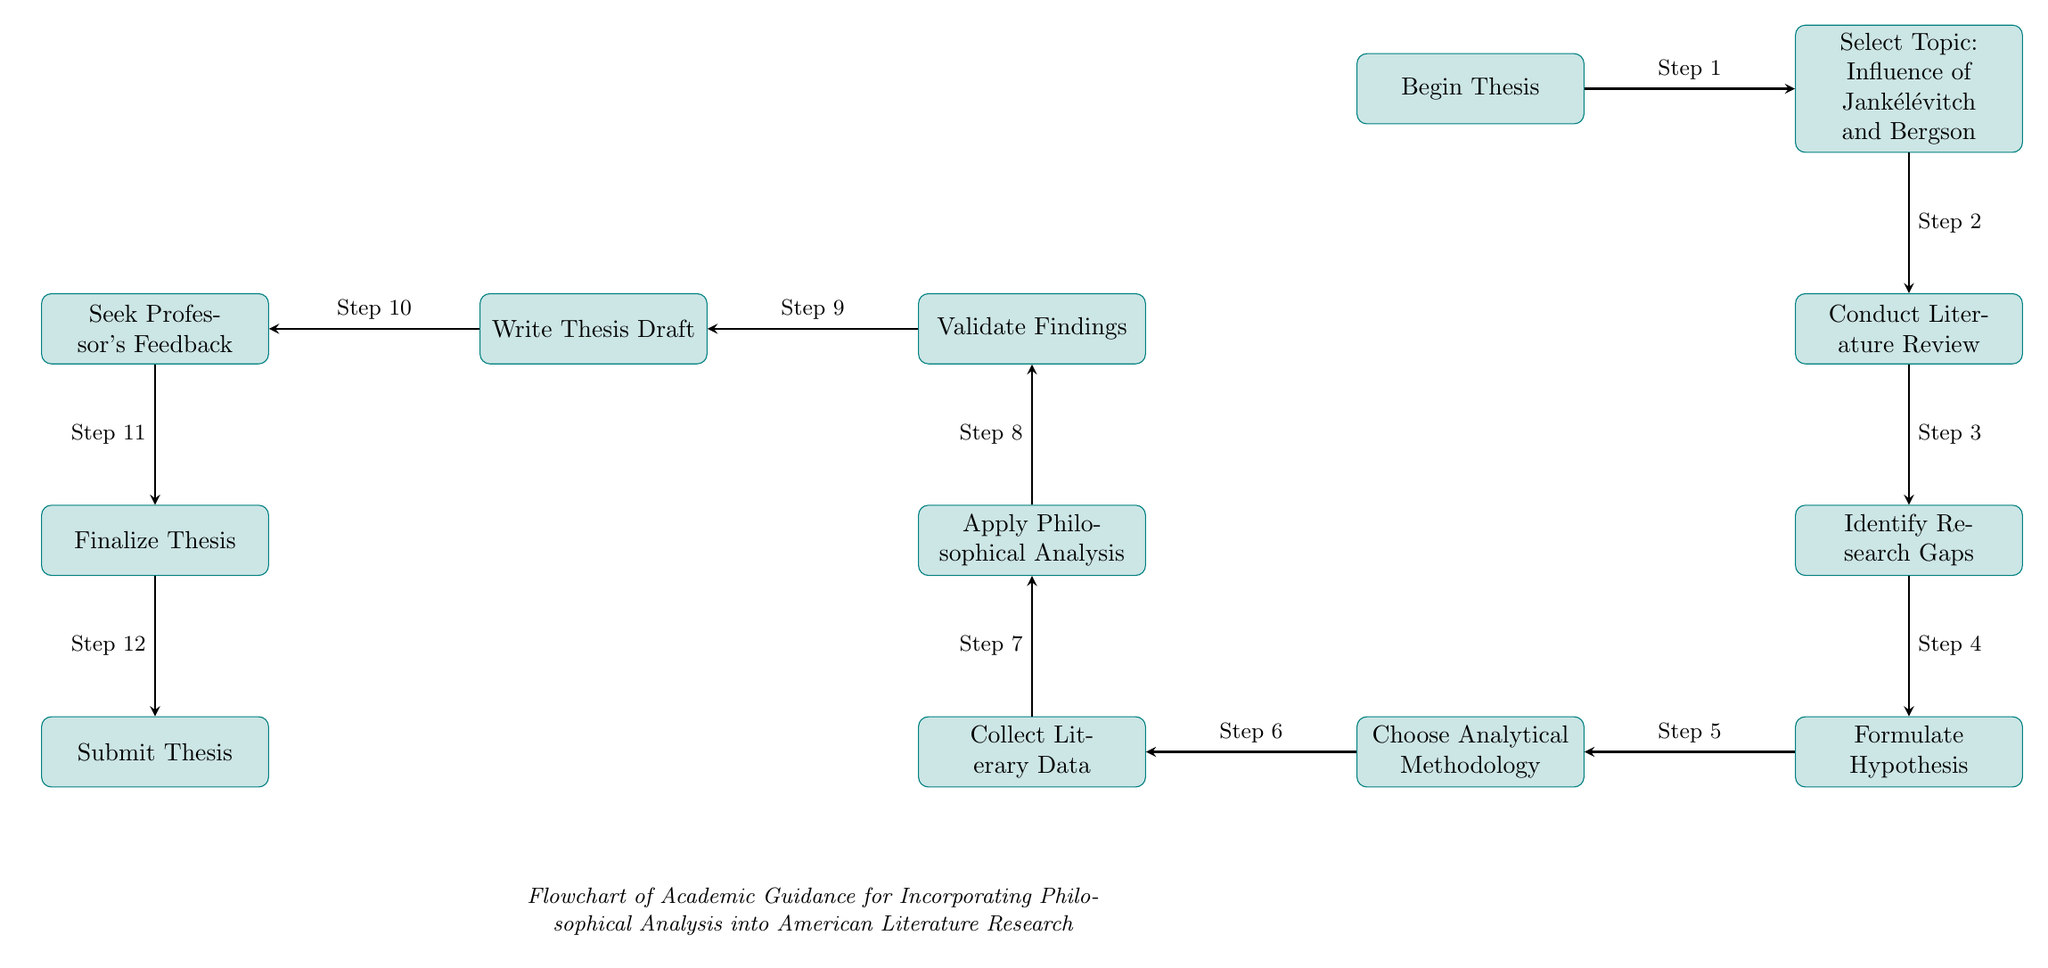What is the first step in the flowchart? The first step in the flowchart is indicated by the top node labeled "Begin Thesis." This is positioned at the starting point of the diagram.
Answer: Begin Thesis How many total processes are depicted in the diagram? The diagram includes a total of 12 distinct nodes labeled as processes. By counting each process node from "Begin Thesis" to "Submit Thesis," we can verify this total.
Answer: 12 What does the node below "Conduct Literature Review" represent? The node directly below "Conduct Literature Review" is "Identify Research Gaps," which follows naturally in the flow of steps for the thesis process.
Answer: Identify Research Gaps Which step involves collecting data? The step for collecting data is labeled "Collect Literary Data," and it is positioned to the left of the node "Choose Analytical Methodology."
Answer: Collect Literary Data What step comes after "Validate Findings"? The step that comes after "Validate Findings" is "Write Thesis Draft," showing a sequence of actions toward finalizing the thesis.
Answer: Write Thesis Draft Describe the connection between "Seek Professor's Feedback" and "Finalize Thesis." "Seek Professor's Feedback" is the step preceding "Finalize Thesis," indicating that feedback from the professor is necessary before finalizing the thesis.
Answer: Feedback informs Finalization What is the last step in the flowchart? The final step is indicated by the node labeled "Submit Thesis," which signifies the completion of the thesis process represented in the diagram.
Answer: Submit Thesis How do you go from "Formulate Hypothesis" to "Choose Analytical Methodology"? Going from "Formulate Hypothesis," you must move left to the node "Choose Analytical Methodology," indicating an exploratory step where you select the approach before proceeding.
Answer: Move left to Choose Analytical Methodology What do the arrows represent in this flowchart? The arrows in the flowchart represent the sequence of steps and their logical flow from one action to the next, indicating the order in which tasks should be performed.
Answer: Sequence of steps 